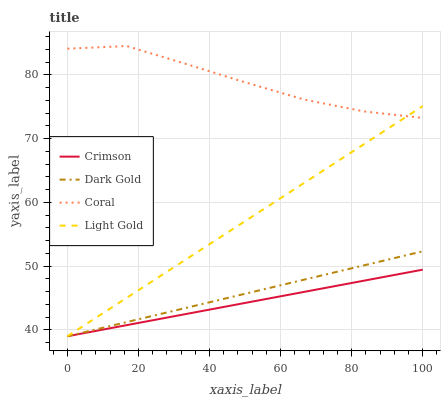Does Crimson have the minimum area under the curve?
Answer yes or no. Yes. Does Coral have the maximum area under the curve?
Answer yes or no. Yes. Does Light Gold have the minimum area under the curve?
Answer yes or no. No. Does Light Gold have the maximum area under the curve?
Answer yes or no. No. Is Crimson the smoothest?
Answer yes or no. Yes. Is Coral the roughest?
Answer yes or no. Yes. Is Light Gold the smoothest?
Answer yes or no. No. Is Light Gold the roughest?
Answer yes or no. No. Does Crimson have the lowest value?
Answer yes or no. Yes. Does Coral have the lowest value?
Answer yes or no. No. Does Coral have the highest value?
Answer yes or no. Yes. Does Light Gold have the highest value?
Answer yes or no. No. Is Crimson less than Coral?
Answer yes or no. Yes. Is Coral greater than Dark Gold?
Answer yes or no. Yes. Does Dark Gold intersect Crimson?
Answer yes or no. Yes. Is Dark Gold less than Crimson?
Answer yes or no. No. Is Dark Gold greater than Crimson?
Answer yes or no. No. Does Crimson intersect Coral?
Answer yes or no. No. 